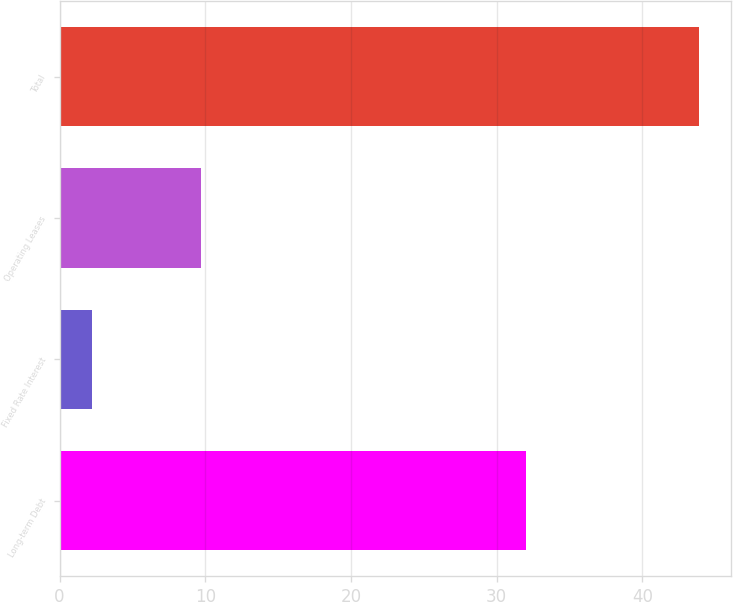Convert chart to OTSL. <chart><loc_0><loc_0><loc_500><loc_500><bar_chart><fcel>Long-term Debt<fcel>Fixed Rate Interest<fcel>Operating Leases<fcel>Total<nl><fcel>32<fcel>2.2<fcel>9.7<fcel>43.9<nl></chart> 